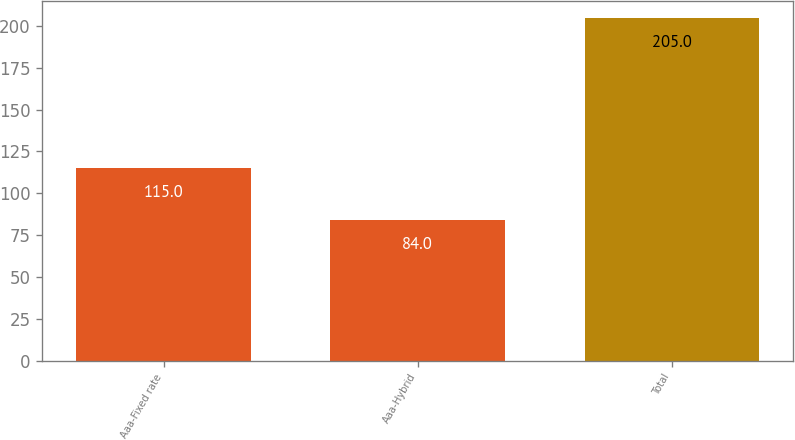<chart> <loc_0><loc_0><loc_500><loc_500><bar_chart><fcel>Aaa-Fixed rate<fcel>Aaa-Hybrid<fcel>Total<nl><fcel>115<fcel>84<fcel>205<nl></chart> 